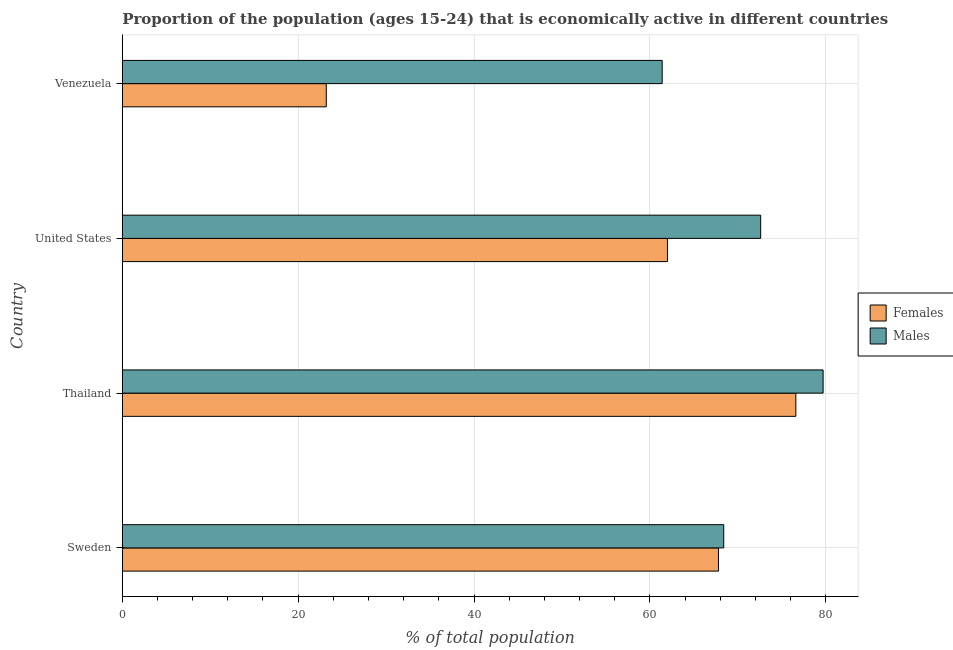How many groups of bars are there?
Provide a short and direct response. 4. Are the number of bars on each tick of the Y-axis equal?
Provide a succinct answer. Yes. What is the label of the 1st group of bars from the top?
Offer a terse response. Venezuela. In how many cases, is the number of bars for a given country not equal to the number of legend labels?
Your response must be concise. 0. What is the percentage of economically active male population in Thailand?
Make the answer very short. 79.7. Across all countries, what is the maximum percentage of economically active female population?
Your response must be concise. 76.6. Across all countries, what is the minimum percentage of economically active male population?
Your answer should be compact. 61.4. In which country was the percentage of economically active female population maximum?
Give a very brief answer. Thailand. In which country was the percentage of economically active male population minimum?
Make the answer very short. Venezuela. What is the total percentage of economically active male population in the graph?
Make the answer very short. 282.1. What is the difference between the percentage of economically active male population in United States and the percentage of economically active female population in Thailand?
Keep it short and to the point. -4. What is the average percentage of economically active male population per country?
Give a very brief answer. 70.53. What is the ratio of the percentage of economically active male population in Sweden to that in United States?
Make the answer very short. 0.94. What is the difference between the highest and the second highest percentage of economically active male population?
Keep it short and to the point. 7.1. Is the sum of the percentage of economically active male population in Sweden and Thailand greater than the maximum percentage of economically active female population across all countries?
Make the answer very short. Yes. What does the 2nd bar from the top in Venezuela represents?
Give a very brief answer. Females. What does the 2nd bar from the bottom in Thailand represents?
Your answer should be very brief. Males. Are all the bars in the graph horizontal?
Keep it short and to the point. Yes. How many countries are there in the graph?
Give a very brief answer. 4. What is the difference between two consecutive major ticks on the X-axis?
Provide a succinct answer. 20. Where does the legend appear in the graph?
Give a very brief answer. Center right. How are the legend labels stacked?
Offer a terse response. Vertical. What is the title of the graph?
Offer a very short reply. Proportion of the population (ages 15-24) that is economically active in different countries. Does "US$" appear as one of the legend labels in the graph?
Give a very brief answer. No. What is the label or title of the X-axis?
Provide a succinct answer. % of total population. What is the label or title of the Y-axis?
Offer a terse response. Country. What is the % of total population of Females in Sweden?
Provide a short and direct response. 67.8. What is the % of total population of Males in Sweden?
Give a very brief answer. 68.4. What is the % of total population of Females in Thailand?
Make the answer very short. 76.6. What is the % of total population of Males in Thailand?
Make the answer very short. 79.7. What is the % of total population of Males in United States?
Offer a very short reply. 72.6. What is the % of total population of Females in Venezuela?
Your response must be concise. 23.2. What is the % of total population in Males in Venezuela?
Your answer should be compact. 61.4. Across all countries, what is the maximum % of total population of Females?
Make the answer very short. 76.6. Across all countries, what is the maximum % of total population of Males?
Ensure brevity in your answer.  79.7. Across all countries, what is the minimum % of total population of Females?
Provide a succinct answer. 23.2. Across all countries, what is the minimum % of total population of Males?
Ensure brevity in your answer.  61.4. What is the total % of total population of Females in the graph?
Offer a terse response. 229.6. What is the total % of total population in Males in the graph?
Ensure brevity in your answer.  282.1. What is the difference between the % of total population in Females in Sweden and that in Thailand?
Your answer should be compact. -8.8. What is the difference between the % of total population in Males in Sweden and that in United States?
Your answer should be compact. -4.2. What is the difference between the % of total population in Females in Sweden and that in Venezuela?
Provide a succinct answer. 44.6. What is the difference between the % of total population of Females in Thailand and that in Venezuela?
Your answer should be compact. 53.4. What is the difference between the % of total population in Males in Thailand and that in Venezuela?
Ensure brevity in your answer.  18.3. What is the difference between the % of total population in Females in United States and that in Venezuela?
Provide a short and direct response. 38.8. What is the difference between the % of total population of Females in Sweden and the % of total population of Males in Thailand?
Give a very brief answer. -11.9. What is the difference between the % of total population in Females in Sweden and the % of total population in Males in United States?
Provide a succinct answer. -4.8. What is the difference between the % of total population in Females in Sweden and the % of total population in Males in Venezuela?
Keep it short and to the point. 6.4. What is the difference between the % of total population of Females in Thailand and the % of total population of Males in United States?
Your response must be concise. 4. What is the difference between the % of total population of Females in Thailand and the % of total population of Males in Venezuela?
Provide a succinct answer. 15.2. What is the average % of total population of Females per country?
Provide a succinct answer. 57.4. What is the average % of total population in Males per country?
Offer a very short reply. 70.53. What is the difference between the % of total population of Females and % of total population of Males in Sweden?
Give a very brief answer. -0.6. What is the difference between the % of total population of Females and % of total population of Males in Thailand?
Make the answer very short. -3.1. What is the difference between the % of total population in Females and % of total population in Males in Venezuela?
Your answer should be compact. -38.2. What is the ratio of the % of total population of Females in Sweden to that in Thailand?
Keep it short and to the point. 0.89. What is the ratio of the % of total population in Males in Sweden to that in Thailand?
Ensure brevity in your answer.  0.86. What is the ratio of the % of total population in Females in Sweden to that in United States?
Make the answer very short. 1.09. What is the ratio of the % of total population of Males in Sweden to that in United States?
Make the answer very short. 0.94. What is the ratio of the % of total population of Females in Sweden to that in Venezuela?
Keep it short and to the point. 2.92. What is the ratio of the % of total population in Males in Sweden to that in Venezuela?
Offer a very short reply. 1.11. What is the ratio of the % of total population in Females in Thailand to that in United States?
Offer a very short reply. 1.24. What is the ratio of the % of total population of Males in Thailand to that in United States?
Your answer should be compact. 1.1. What is the ratio of the % of total population in Females in Thailand to that in Venezuela?
Give a very brief answer. 3.3. What is the ratio of the % of total population in Males in Thailand to that in Venezuela?
Your response must be concise. 1.3. What is the ratio of the % of total population of Females in United States to that in Venezuela?
Your answer should be very brief. 2.67. What is the ratio of the % of total population of Males in United States to that in Venezuela?
Give a very brief answer. 1.18. What is the difference between the highest and the second highest % of total population of Females?
Offer a very short reply. 8.8. What is the difference between the highest and the second highest % of total population in Males?
Your answer should be compact. 7.1. What is the difference between the highest and the lowest % of total population in Females?
Offer a very short reply. 53.4. 